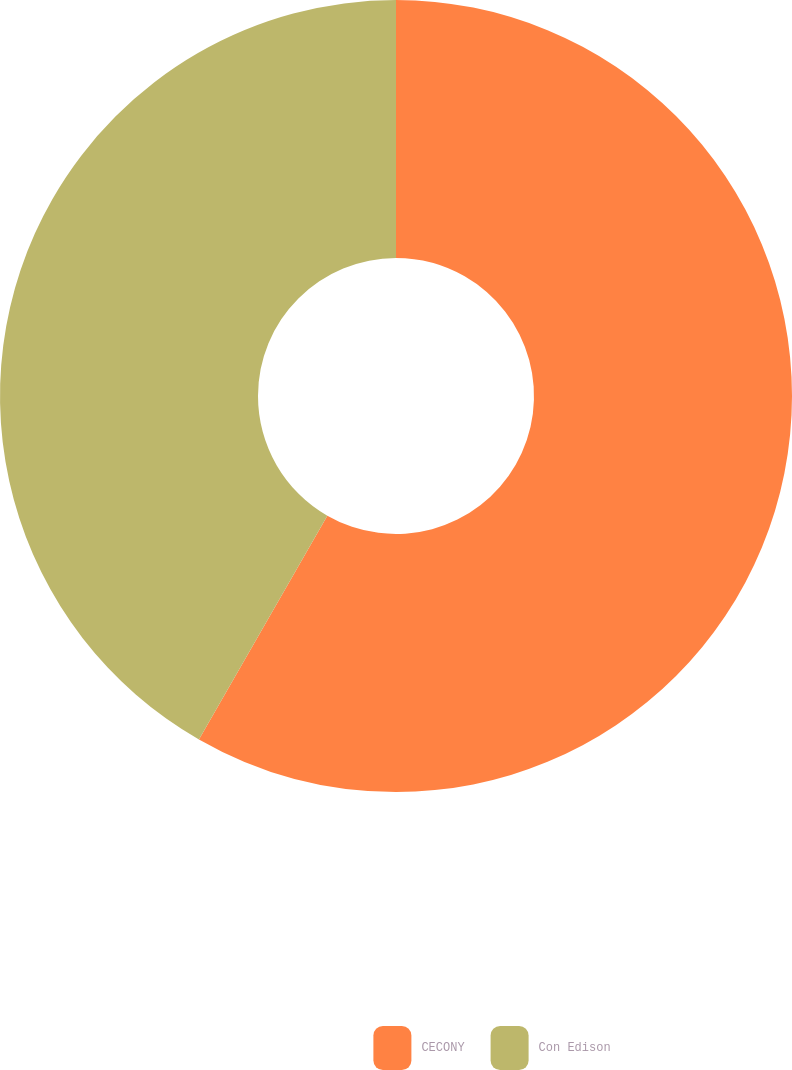Convert chart to OTSL. <chart><loc_0><loc_0><loc_500><loc_500><pie_chart><fcel>CECONY<fcel>Con Edison<nl><fcel>58.29%<fcel>41.71%<nl></chart> 